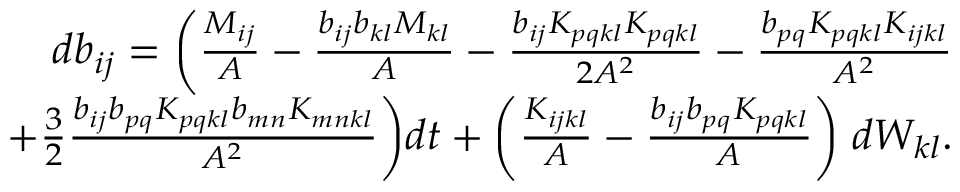Convert formula to latex. <formula><loc_0><loc_0><loc_500><loc_500>\begin{array} { r } { d b _ { i j } = \left ( \frac { M _ { i j } } { A } - \frac { b _ { i j } b _ { k l } M _ { k l } } { A } - \frac { b _ { i j } K _ { p q k l } K _ { p q k l } } { 2 A ^ { 2 } } - \frac { b _ { p q } K _ { p q k l } K _ { i j k l } } { A ^ { 2 } } } \\ { + \frac { 3 } { 2 } \frac { b _ { i j } b _ { p q } K _ { p q k l } b _ { m n } K _ { m n k l } } { A ^ { 2 } } \right ) d t + \left ( \frac { K _ { i j k l } } { A } - \frac { b _ { i j } b _ { p q } K _ { p q k l } } { A } \right ) \, d W _ { k l } . } \end{array}</formula> 